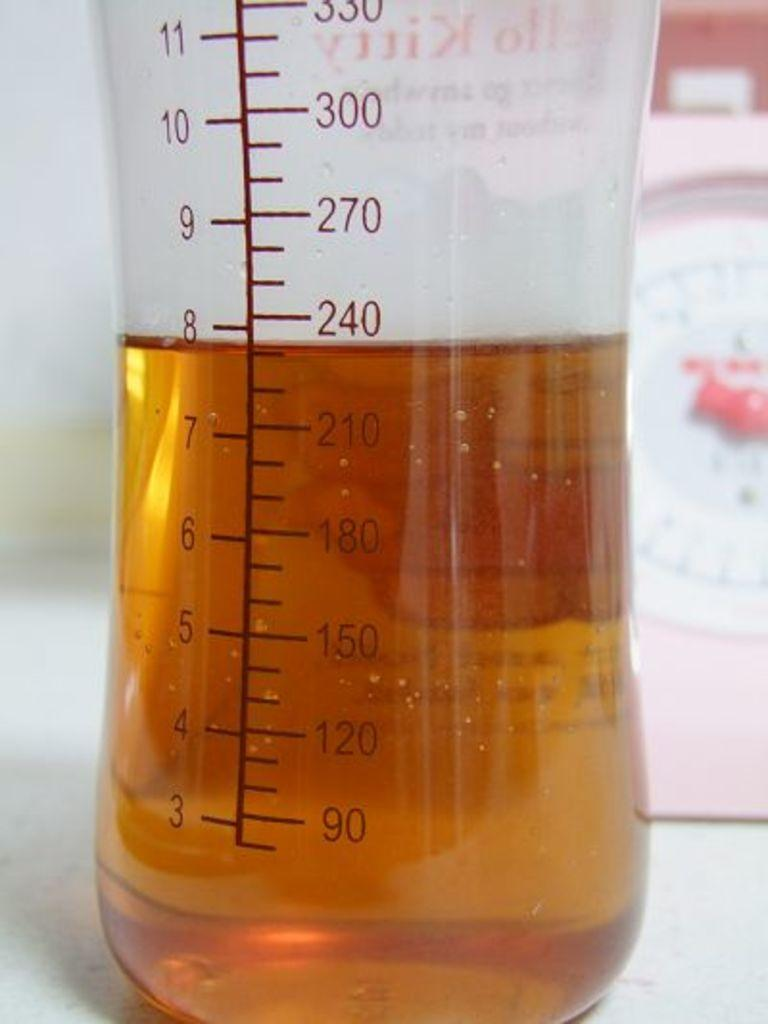<image>
Present a compact description of the photo's key features. measuring cup with gold liquid inside that measure 8" 